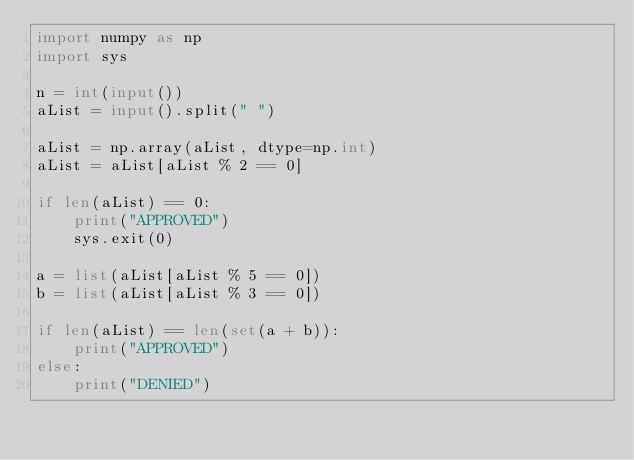<code> <loc_0><loc_0><loc_500><loc_500><_Python_>import numpy as np
import sys

n = int(input())
aList = input().split(" ")

aList = np.array(aList, dtype=np.int)
aList = aList[aList % 2 == 0]

if len(aList) == 0:
    print("APPROVED")
    sys.exit(0)

a = list(aList[aList % 5 == 0])
b = list(aList[aList % 3 == 0])

if len(aList) == len(set(a + b)):
    print("APPROVED")
else:
    print("DENIED")</code> 